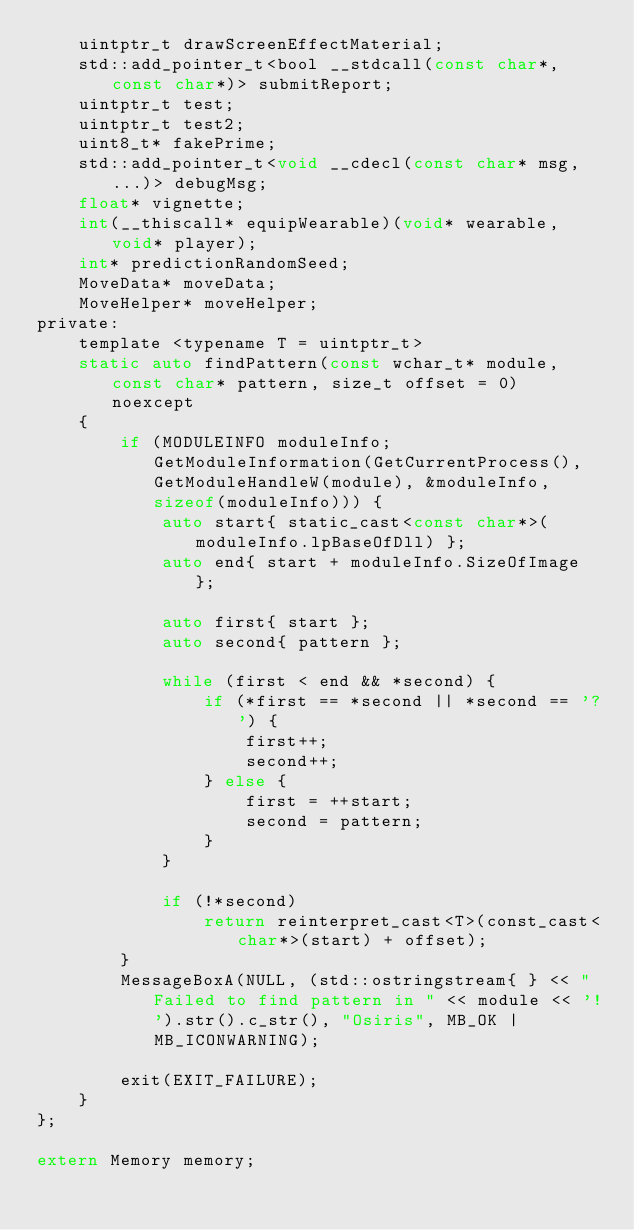<code> <loc_0><loc_0><loc_500><loc_500><_C_>    uintptr_t drawScreenEffectMaterial;
    std::add_pointer_t<bool __stdcall(const char*, const char*)> submitReport;
    uintptr_t test;
    uintptr_t test2;
    uint8_t* fakePrime;
    std::add_pointer_t<void __cdecl(const char* msg, ...)> debugMsg;
    float* vignette;
    int(__thiscall* equipWearable)(void* wearable, void* player);
    int* predictionRandomSeed;
    MoveData* moveData;
    MoveHelper* moveHelper;
private:
    template <typename T = uintptr_t>
    static auto findPattern(const wchar_t* module, const char* pattern, size_t offset = 0) noexcept
    {
        if (MODULEINFO moduleInfo; GetModuleInformation(GetCurrentProcess(), GetModuleHandleW(module), &moduleInfo, sizeof(moduleInfo))) {
            auto start{ static_cast<const char*>(moduleInfo.lpBaseOfDll) };
            auto end{ start + moduleInfo.SizeOfImage };

            auto first{ start };
            auto second{ pattern };

            while (first < end && *second) {
                if (*first == *second || *second == '?') {
                    first++;
                    second++;
                } else {
                    first = ++start;
                    second = pattern;
                }
            }

            if (!*second)
                return reinterpret_cast<T>(const_cast<char*>(start) + offset);
        }
        MessageBoxA(NULL, (std::ostringstream{ } << "Failed to find pattern in " << module << '!').str().c_str(), "Osiris", MB_OK | MB_ICONWARNING);
     
        exit(EXIT_FAILURE);
    }
};

extern Memory memory;
</code> 